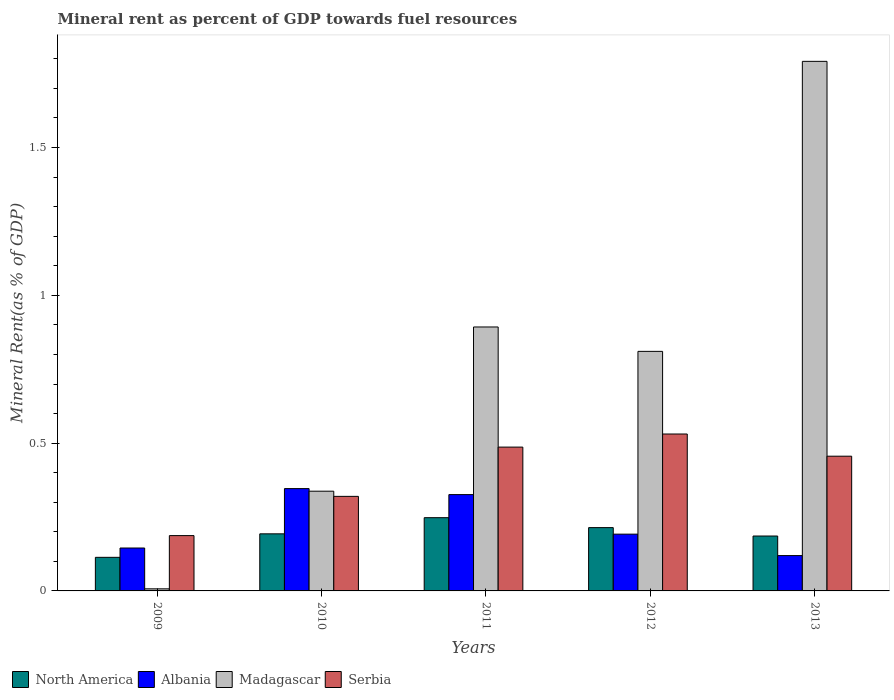How many different coloured bars are there?
Offer a terse response. 4. How many groups of bars are there?
Offer a terse response. 5. Are the number of bars per tick equal to the number of legend labels?
Keep it short and to the point. Yes. Are the number of bars on each tick of the X-axis equal?
Provide a succinct answer. Yes. How many bars are there on the 3rd tick from the right?
Provide a short and direct response. 4. In how many cases, is the number of bars for a given year not equal to the number of legend labels?
Your answer should be compact. 0. What is the mineral rent in Albania in 2011?
Keep it short and to the point. 0.33. Across all years, what is the maximum mineral rent in Madagascar?
Offer a very short reply. 1.79. Across all years, what is the minimum mineral rent in Serbia?
Ensure brevity in your answer.  0.19. In which year was the mineral rent in North America maximum?
Offer a terse response. 2011. What is the total mineral rent in Serbia in the graph?
Provide a short and direct response. 1.98. What is the difference between the mineral rent in Albania in 2010 and that in 2011?
Offer a terse response. 0.02. What is the difference between the mineral rent in Albania in 2011 and the mineral rent in North America in 2010?
Keep it short and to the point. 0.13. What is the average mineral rent in Albania per year?
Keep it short and to the point. 0.23. In the year 2011, what is the difference between the mineral rent in North America and mineral rent in Serbia?
Give a very brief answer. -0.24. What is the ratio of the mineral rent in North America in 2010 to that in 2012?
Provide a succinct answer. 0.9. Is the mineral rent in Madagascar in 2010 less than that in 2012?
Ensure brevity in your answer.  Yes. Is the difference between the mineral rent in North America in 2009 and 2012 greater than the difference between the mineral rent in Serbia in 2009 and 2012?
Ensure brevity in your answer.  Yes. What is the difference between the highest and the second highest mineral rent in Albania?
Make the answer very short. 0.02. What is the difference between the highest and the lowest mineral rent in Madagascar?
Your response must be concise. 1.78. In how many years, is the mineral rent in Albania greater than the average mineral rent in Albania taken over all years?
Provide a succinct answer. 2. Is the sum of the mineral rent in Serbia in 2011 and 2013 greater than the maximum mineral rent in Madagascar across all years?
Offer a terse response. No. Is it the case that in every year, the sum of the mineral rent in Madagascar and mineral rent in North America is greater than the sum of mineral rent in Serbia and mineral rent in Albania?
Keep it short and to the point. No. What does the 4th bar from the left in 2010 represents?
Your response must be concise. Serbia. What does the 1st bar from the right in 2012 represents?
Give a very brief answer. Serbia. Are the values on the major ticks of Y-axis written in scientific E-notation?
Your answer should be compact. No. Does the graph contain any zero values?
Your answer should be very brief. No. Where does the legend appear in the graph?
Give a very brief answer. Bottom left. How many legend labels are there?
Provide a succinct answer. 4. How are the legend labels stacked?
Provide a short and direct response. Horizontal. What is the title of the graph?
Keep it short and to the point. Mineral rent as percent of GDP towards fuel resources. Does "Namibia" appear as one of the legend labels in the graph?
Your response must be concise. No. What is the label or title of the Y-axis?
Offer a terse response. Mineral Rent(as % of GDP). What is the Mineral Rent(as % of GDP) of North America in 2009?
Keep it short and to the point. 0.11. What is the Mineral Rent(as % of GDP) in Albania in 2009?
Provide a succinct answer. 0.15. What is the Mineral Rent(as % of GDP) of Madagascar in 2009?
Offer a very short reply. 0.01. What is the Mineral Rent(as % of GDP) in Serbia in 2009?
Provide a succinct answer. 0.19. What is the Mineral Rent(as % of GDP) of North America in 2010?
Your answer should be very brief. 0.19. What is the Mineral Rent(as % of GDP) of Albania in 2010?
Give a very brief answer. 0.35. What is the Mineral Rent(as % of GDP) of Madagascar in 2010?
Offer a terse response. 0.34. What is the Mineral Rent(as % of GDP) of Serbia in 2010?
Your answer should be compact. 0.32. What is the Mineral Rent(as % of GDP) of North America in 2011?
Provide a succinct answer. 0.25. What is the Mineral Rent(as % of GDP) in Albania in 2011?
Your answer should be compact. 0.33. What is the Mineral Rent(as % of GDP) of Madagascar in 2011?
Keep it short and to the point. 0.89. What is the Mineral Rent(as % of GDP) of Serbia in 2011?
Keep it short and to the point. 0.49. What is the Mineral Rent(as % of GDP) in North America in 2012?
Offer a terse response. 0.21. What is the Mineral Rent(as % of GDP) of Albania in 2012?
Your answer should be very brief. 0.19. What is the Mineral Rent(as % of GDP) in Madagascar in 2012?
Ensure brevity in your answer.  0.81. What is the Mineral Rent(as % of GDP) of Serbia in 2012?
Your response must be concise. 0.53. What is the Mineral Rent(as % of GDP) of North America in 2013?
Provide a short and direct response. 0.19. What is the Mineral Rent(as % of GDP) in Albania in 2013?
Your response must be concise. 0.12. What is the Mineral Rent(as % of GDP) in Madagascar in 2013?
Provide a short and direct response. 1.79. What is the Mineral Rent(as % of GDP) in Serbia in 2013?
Provide a succinct answer. 0.46. Across all years, what is the maximum Mineral Rent(as % of GDP) of North America?
Ensure brevity in your answer.  0.25. Across all years, what is the maximum Mineral Rent(as % of GDP) in Albania?
Provide a succinct answer. 0.35. Across all years, what is the maximum Mineral Rent(as % of GDP) in Madagascar?
Make the answer very short. 1.79. Across all years, what is the maximum Mineral Rent(as % of GDP) of Serbia?
Your answer should be compact. 0.53. Across all years, what is the minimum Mineral Rent(as % of GDP) of North America?
Offer a very short reply. 0.11. Across all years, what is the minimum Mineral Rent(as % of GDP) in Albania?
Keep it short and to the point. 0.12. Across all years, what is the minimum Mineral Rent(as % of GDP) of Madagascar?
Ensure brevity in your answer.  0.01. Across all years, what is the minimum Mineral Rent(as % of GDP) in Serbia?
Offer a very short reply. 0.19. What is the total Mineral Rent(as % of GDP) of North America in the graph?
Your answer should be compact. 0.95. What is the total Mineral Rent(as % of GDP) in Albania in the graph?
Your answer should be very brief. 1.13. What is the total Mineral Rent(as % of GDP) of Madagascar in the graph?
Your answer should be very brief. 3.84. What is the total Mineral Rent(as % of GDP) in Serbia in the graph?
Your answer should be compact. 1.98. What is the difference between the Mineral Rent(as % of GDP) in North America in 2009 and that in 2010?
Your answer should be very brief. -0.08. What is the difference between the Mineral Rent(as % of GDP) in Albania in 2009 and that in 2010?
Provide a succinct answer. -0.2. What is the difference between the Mineral Rent(as % of GDP) in Madagascar in 2009 and that in 2010?
Your answer should be very brief. -0.33. What is the difference between the Mineral Rent(as % of GDP) of Serbia in 2009 and that in 2010?
Provide a succinct answer. -0.13. What is the difference between the Mineral Rent(as % of GDP) of North America in 2009 and that in 2011?
Give a very brief answer. -0.13. What is the difference between the Mineral Rent(as % of GDP) of Albania in 2009 and that in 2011?
Offer a terse response. -0.18. What is the difference between the Mineral Rent(as % of GDP) of Madagascar in 2009 and that in 2011?
Offer a very short reply. -0.89. What is the difference between the Mineral Rent(as % of GDP) of Serbia in 2009 and that in 2011?
Give a very brief answer. -0.3. What is the difference between the Mineral Rent(as % of GDP) of North America in 2009 and that in 2012?
Provide a succinct answer. -0.1. What is the difference between the Mineral Rent(as % of GDP) of Albania in 2009 and that in 2012?
Make the answer very short. -0.05. What is the difference between the Mineral Rent(as % of GDP) of Madagascar in 2009 and that in 2012?
Offer a very short reply. -0.8. What is the difference between the Mineral Rent(as % of GDP) in Serbia in 2009 and that in 2012?
Ensure brevity in your answer.  -0.34. What is the difference between the Mineral Rent(as % of GDP) in North America in 2009 and that in 2013?
Give a very brief answer. -0.07. What is the difference between the Mineral Rent(as % of GDP) of Albania in 2009 and that in 2013?
Ensure brevity in your answer.  0.03. What is the difference between the Mineral Rent(as % of GDP) in Madagascar in 2009 and that in 2013?
Make the answer very short. -1.78. What is the difference between the Mineral Rent(as % of GDP) of Serbia in 2009 and that in 2013?
Give a very brief answer. -0.27. What is the difference between the Mineral Rent(as % of GDP) in North America in 2010 and that in 2011?
Your answer should be compact. -0.05. What is the difference between the Mineral Rent(as % of GDP) in Albania in 2010 and that in 2011?
Offer a very short reply. 0.02. What is the difference between the Mineral Rent(as % of GDP) of Madagascar in 2010 and that in 2011?
Offer a terse response. -0.56. What is the difference between the Mineral Rent(as % of GDP) of North America in 2010 and that in 2012?
Your answer should be compact. -0.02. What is the difference between the Mineral Rent(as % of GDP) of Albania in 2010 and that in 2012?
Your answer should be very brief. 0.15. What is the difference between the Mineral Rent(as % of GDP) of Madagascar in 2010 and that in 2012?
Ensure brevity in your answer.  -0.47. What is the difference between the Mineral Rent(as % of GDP) in Serbia in 2010 and that in 2012?
Your answer should be very brief. -0.21. What is the difference between the Mineral Rent(as % of GDP) in North America in 2010 and that in 2013?
Provide a succinct answer. 0.01. What is the difference between the Mineral Rent(as % of GDP) in Albania in 2010 and that in 2013?
Your answer should be compact. 0.23. What is the difference between the Mineral Rent(as % of GDP) in Madagascar in 2010 and that in 2013?
Offer a very short reply. -1.45. What is the difference between the Mineral Rent(as % of GDP) in Serbia in 2010 and that in 2013?
Provide a succinct answer. -0.14. What is the difference between the Mineral Rent(as % of GDP) in North America in 2011 and that in 2012?
Make the answer very short. 0.03. What is the difference between the Mineral Rent(as % of GDP) in Albania in 2011 and that in 2012?
Your answer should be compact. 0.13. What is the difference between the Mineral Rent(as % of GDP) in Madagascar in 2011 and that in 2012?
Your answer should be compact. 0.08. What is the difference between the Mineral Rent(as % of GDP) in Serbia in 2011 and that in 2012?
Provide a short and direct response. -0.04. What is the difference between the Mineral Rent(as % of GDP) in North America in 2011 and that in 2013?
Your response must be concise. 0.06. What is the difference between the Mineral Rent(as % of GDP) of Albania in 2011 and that in 2013?
Offer a terse response. 0.21. What is the difference between the Mineral Rent(as % of GDP) in Madagascar in 2011 and that in 2013?
Provide a short and direct response. -0.9. What is the difference between the Mineral Rent(as % of GDP) in Serbia in 2011 and that in 2013?
Your response must be concise. 0.03. What is the difference between the Mineral Rent(as % of GDP) in North America in 2012 and that in 2013?
Offer a terse response. 0.03. What is the difference between the Mineral Rent(as % of GDP) in Albania in 2012 and that in 2013?
Offer a terse response. 0.07. What is the difference between the Mineral Rent(as % of GDP) in Madagascar in 2012 and that in 2013?
Keep it short and to the point. -0.98. What is the difference between the Mineral Rent(as % of GDP) in Serbia in 2012 and that in 2013?
Keep it short and to the point. 0.07. What is the difference between the Mineral Rent(as % of GDP) of North America in 2009 and the Mineral Rent(as % of GDP) of Albania in 2010?
Ensure brevity in your answer.  -0.23. What is the difference between the Mineral Rent(as % of GDP) in North America in 2009 and the Mineral Rent(as % of GDP) in Madagascar in 2010?
Give a very brief answer. -0.22. What is the difference between the Mineral Rent(as % of GDP) of North America in 2009 and the Mineral Rent(as % of GDP) of Serbia in 2010?
Offer a very short reply. -0.21. What is the difference between the Mineral Rent(as % of GDP) of Albania in 2009 and the Mineral Rent(as % of GDP) of Madagascar in 2010?
Your answer should be very brief. -0.19. What is the difference between the Mineral Rent(as % of GDP) in Albania in 2009 and the Mineral Rent(as % of GDP) in Serbia in 2010?
Ensure brevity in your answer.  -0.17. What is the difference between the Mineral Rent(as % of GDP) in Madagascar in 2009 and the Mineral Rent(as % of GDP) in Serbia in 2010?
Keep it short and to the point. -0.31. What is the difference between the Mineral Rent(as % of GDP) of North America in 2009 and the Mineral Rent(as % of GDP) of Albania in 2011?
Your response must be concise. -0.21. What is the difference between the Mineral Rent(as % of GDP) of North America in 2009 and the Mineral Rent(as % of GDP) of Madagascar in 2011?
Offer a very short reply. -0.78. What is the difference between the Mineral Rent(as % of GDP) of North America in 2009 and the Mineral Rent(as % of GDP) of Serbia in 2011?
Offer a very short reply. -0.37. What is the difference between the Mineral Rent(as % of GDP) in Albania in 2009 and the Mineral Rent(as % of GDP) in Madagascar in 2011?
Offer a terse response. -0.75. What is the difference between the Mineral Rent(as % of GDP) of Albania in 2009 and the Mineral Rent(as % of GDP) of Serbia in 2011?
Keep it short and to the point. -0.34. What is the difference between the Mineral Rent(as % of GDP) of Madagascar in 2009 and the Mineral Rent(as % of GDP) of Serbia in 2011?
Your answer should be compact. -0.48. What is the difference between the Mineral Rent(as % of GDP) of North America in 2009 and the Mineral Rent(as % of GDP) of Albania in 2012?
Your answer should be compact. -0.08. What is the difference between the Mineral Rent(as % of GDP) in North America in 2009 and the Mineral Rent(as % of GDP) in Madagascar in 2012?
Give a very brief answer. -0.7. What is the difference between the Mineral Rent(as % of GDP) of North America in 2009 and the Mineral Rent(as % of GDP) of Serbia in 2012?
Provide a short and direct response. -0.42. What is the difference between the Mineral Rent(as % of GDP) of Albania in 2009 and the Mineral Rent(as % of GDP) of Madagascar in 2012?
Your answer should be compact. -0.67. What is the difference between the Mineral Rent(as % of GDP) in Albania in 2009 and the Mineral Rent(as % of GDP) in Serbia in 2012?
Ensure brevity in your answer.  -0.39. What is the difference between the Mineral Rent(as % of GDP) in Madagascar in 2009 and the Mineral Rent(as % of GDP) in Serbia in 2012?
Provide a short and direct response. -0.52. What is the difference between the Mineral Rent(as % of GDP) of North America in 2009 and the Mineral Rent(as % of GDP) of Albania in 2013?
Give a very brief answer. -0.01. What is the difference between the Mineral Rent(as % of GDP) in North America in 2009 and the Mineral Rent(as % of GDP) in Madagascar in 2013?
Your answer should be very brief. -1.68. What is the difference between the Mineral Rent(as % of GDP) in North America in 2009 and the Mineral Rent(as % of GDP) in Serbia in 2013?
Make the answer very short. -0.34. What is the difference between the Mineral Rent(as % of GDP) in Albania in 2009 and the Mineral Rent(as % of GDP) in Madagascar in 2013?
Give a very brief answer. -1.65. What is the difference between the Mineral Rent(as % of GDP) of Albania in 2009 and the Mineral Rent(as % of GDP) of Serbia in 2013?
Keep it short and to the point. -0.31. What is the difference between the Mineral Rent(as % of GDP) in Madagascar in 2009 and the Mineral Rent(as % of GDP) in Serbia in 2013?
Your answer should be very brief. -0.45. What is the difference between the Mineral Rent(as % of GDP) in North America in 2010 and the Mineral Rent(as % of GDP) in Albania in 2011?
Keep it short and to the point. -0.13. What is the difference between the Mineral Rent(as % of GDP) of North America in 2010 and the Mineral Rent(as % of GDP) of Madagascar in 2011?
Ensure brevity in your answer.  -0.7. What is the difference between the Mineral Rent(as % of GDP) of North America in 2010 and the Mineral Rent(as % of GDP) of Serbia in 2011?
Your response must be concise. -0.29. What is the difference between the Mineral Rent(as % of GDP) in Albania in 2010 and the Mineral Rent(as % of GDP) in Madagascar in 2011?
Your response must be concise. -0.55. What is the difference between the Mineral Rent(as % of GDP) of Albania in 2010 and the Mineral Rent(as % of GDP) of Serbia in 2011?
Your response must be concise. -0.14. What is the difference between the Mineral Rent(as % of GDP) in Madagascar in 2010 and the Mineral Rent(as % of GDP) in Serbia in 2011?
Your response must be concise. -0.15. What is the difference between the Mineral Rent(as % of GDP) of North America in 2010 and the Mineral Rent(as % of GDP) of Albania in 2012?
Make the answer very short. 0. What is the difference between the Mineral Rent(as % of GDP) of North America in 2010 and the Mineral Rent(as % of GDP) of Madagascar in 2012?
Your answer should be compact. -0.62. What is the difference between the Mineral Rent(as % of GDP) of North America in 2010 and the Mineral Rent(as % of GDP) of Serbia in 2012?
Give a very brief answer. -0.34. What is the difference between the Mineral Rent(as % of GDP) of Albania in 2010 and the Mineral Rent(as % of GDP) of Madagascar in 2012?
Your answer should be very brief. -0.46. What is the difference between the Mineral Rent(as % of GDP) in Albania in 2010 and the Mineral Rent(as % of GDP) in Serbia in 2012?
Ensure brevity in your answer.  -0.18. What is the difference between the Mineral Rent(as % of GDP) of Madagascar in 2010 and the Mineral Rent(as % of GDP) of Serbia in 2012?
Offer a very short reply. -0.19. What is the difference between the Mineral Rent(as % of GDP) of North America in 2010 and the Mineral Rent(as % of GDP) of Albania in 2013?
Make the answer very short. 0.07. What is the difference between the Mineral Rent(as % of GDP) in North America in 2010 and the Mineral Rent(as % of GDP) in Madagascar in 2013?
Your answer should be compact. -1.6. What is the difference between the Mineral Rent(as % of GDP) in North America in 2010 and the Mineral Rent(as % of GDP) in Serbia in 2013?
Your answer should be very brief. -0.26. What is the difference between the Mineral Rent(as % of GDP) in Albania in 2010 and the Mineral Rent(as % of GDP) in Madagascar in 2013?
Offer a very short reply. -1.45. What is the difference between the Mineral Rent(as % of GDP) in Albania in 2010 and the Mineral Rent(as % of GDP) in Serbia in 2013?
Give a very brief answer. -0.11. What is the difference between the Mineral Rent(as % of GDP) of Madagascar in 2010 and the Mineral Rent(as % of GDP) of Serbia in 2013?
Provide a short and direct response. -0.12. What is the difference between the Mineral Rent(as % of GDP) of North America in 2011 and the Mineral Rent(as % of GDP) of Albania in 2012?
Provide a succinct answer. 0.06. What is the difference between the Mineral Rent(as % of GDP) in North America in 2011 and the Mineral Rent(as % of GDP) in Madagascar in 2012?
Your answer should be compact. -0.56. What is the difference between the Mineral Rent(as % of GDP) in North America in 2011 and the Mineral Rent(as % of GDP) in Serbia in 2012?
Offer a very short reply. -0.28. What is the difference between the Mineral Rent(as % of GDP) of Albania in 2011 and the Mineral Rent(as % of GDP) of Madagascar in 2012?
Make the answer very short. -0.48. What is the difference between the Mineral Rent(as % of GDP) in Albania in 2011 and the Mineral Rent(as % of GDP) in Serbia in 2012?
Offer a terse response. -0.2. What is the difference between the Mineral Rent(as % of GDP) of Madagascar in 2011 and the Mineral Rent(as % of GDP) of Serbia in 2012?
Offer a very short reply. 0.36. What is the difference between the Mineral Rent(as % of GDP) of North America in 2011 and the Mineral Rent(as % of GDP) of Albania in 2013?
Ensure brevity in your answer.  0.13. What is the difference between the Mineral Rent(as % of GDP) in North America in 2011 and the Mineral Rent(as % of GDP) in Madagascar in 2013?
Ensure brevity in your answer.  -1.54. What is the difference between the Mineral Rent(as % of GDP) in North America in 2011 and the Mineral Rent(as % of GDP) in Serbia in 2013?
Provide a succinct answer. -0.21. What is the difference between the Mineral Rent(as % of GDP) of Albania in 2011 and the Mineral Rent(as % of GDP) of Madagascar in 2013?
Your answer should be compact. -1.47. What is the difference between the Mineral Rent(as % of GDP) in Albania in 2011 and the Mineral Rent(as % of GDP) in Serbia in 2013?
Make the answer very short. -0.13. What is the difference between the Mineral Rent(as % of GDP) in Madagascar in 2011 and the Mineral Rent(as % of GDP) in Serbia in 2013?
Keep it short and to the point. 0.44. What is the difference between the Mineral Rent(as % of GDP) of North America in 2012 and the Mineral Rent(as % of GDP) of Albania in 2013?
Keep it short and to the point. 0.09. What is the difference between the Mineral Rent(as % of GDP) in North America in 2012 and the Mineral Rent(as % of GDP) in Madagascar in 2013?
Provide a succinct answer. -1.58. What is the difference between the Mineral Rent(as % of GDP) of North America in 2012 and the Mineral Rent(as % of GDP) of Serbia in 2013?
Provide a short and direct response. -0.24. What is the difference between the Mineral Rent(as % of GDP) in Albania in 2012 and the Mineral Rent(as % of GDP) in Madagascar in 2013?
Offer a very short reply. -1.6. What is the difference between the Mineral Rent(as % of GDP) in Albania in 2012 and the Mineral Rent(as % of GDP) in Serbia in 2013?
Offer a very short reply. -0.26. What is the difference between the Mineral Rent(as % of GDP) of Madagascar in 2012 and the Mineral Rent(as % of GDP) of Serbia in 2013?
Offer a very short reply. 0.35. What is the average Mineral Rent(as % of GDP) in North America per year?
Offer a terse response. 0.19. What is the average Mineral Rent(as % of GDP) of Albania per year?
Your answer should be very brief. 0.23. What is the average Mineral Rent(as % of GDP) in Madagascar per year?
Provide a succinct answer. 0.77. What is the average Mineral Rent(as % of GDP) of Serbia per year?
Offer a terse response. 0.4. In the year 2009, what is the difference between the Mineral Rent(as % of GDP) of North America and Mineral Rent(as % of GDP) of Albania?
Your answer should be very brief. -0.03. In the year 2009, what is the difference between the Mineral Rent(as % of GDP) in North America and Mineral Rent(as % of GDP) in Madagascar?
Give a very brief answer. 0.11. In the year 2009, what is the difference between the Mineral Rent(as % of GDP) in North America and Mineral Rent(as % of GDP) in Serbia?
Your response must be concise. -0.07. In the year 2009, what is the difference between the Mineral Rent(as % of GDP) in Albania and Mineral Rent(as % of GDP) in Madagascar?
Offer a very short reply. 0.14. In the year 2009, what is the difference between the Mineral Rent(as % of GDP) in Albania and Mineral Rent(as % of GDP) in Serbia?
Your answer should be very brief. -0.04. In the year 2009, what is the difference between the Mineral Rent(as % of GDP) of Madagascar and Mineral Rent(as % of GDP) of Serbia?
Your response must be concise. -0.18. In the year 2010, what is the difference between the Mineral Rent(as % of GDP) in North America and Mineral Rent(as % of GDP) in Albania?
Give a very brief answer. -0.15. In the year 2010, what is the difference between the Mineral Rent(as % of GDP) in North America and Mineral Rent(as % of GDP) in Madagascar?
Give a very brief answer. -0.14. In the year 2010, what is the difference between the Mineral Rent(as % of GDP) of North America and Mineral Rent(as % of GDP) of Serbia?
Your answer should be compact. -0.13. In the year 2010, what is the difference between the Mineral Rent(as % of GDP) in Albania and Mineral Rent(as % of GDP) in Madagascar?
Give a very brief answer. 0.01. In the year 2010, what is the difference between the Mineral Rent(as % of GDP) of Albania and Mineral Rent(as % of GDP) of Serbia?
Your answer should be compact. 0.03. In the year 2010, what is the difference between the Mineral Rent(as % of GDP) of Madagascar and Mineral Rent(as % of GDP) of Serbia?
Offer a terse response. 0.02. In the year 2011, what is the difference between the Mineral Rent(as % of GDP) in North America and Mineral Rent(as % of GDP) in Albania?
Make the answer very short. -0.08. In the year 2011, what is the difference between the Mineral Rent(as % of GDP) of North America and Mineral Rent(as % of GDP) of Madagascar?
Your answer should be very brief. -0.65. In the year 2011, what is the difference between the Mineral Rent(as % of GDP) in North America and Mineral Rent(as % of GDP) in Serbia?
Your answer should be very brief. -0.24. In the year 2011, what is the difference between the Mineral Rent(as % of GDP) of Albania and Mineral Rent(as % of GDP) of Madagascar?
Your answer should be compact. -0.57. In the year 2011, what is the difference between the Mineral Rent(as % of GDP) in Albania and Mineral Rent(as % of GDP) in Serbia?
Make the answer very short. -0.16. In the year 2011, what is the difference between the Mineral Rent(as % of GDP) of Madagascar and Mineral Rent(as % of GDP) of Serbia?
Offer a very short reply. 0.41. In the year 2012, what is the difference between the Mineral Rent(as % of GDP) of North America and Mineral Rent(as % of GDP) of Albania?
Offer a very short reply. 0.02. In the year 2012, what is the difference between the Mineral Rent(as % of GDP) in North America and Mineral Rent(as % of GDP) in Madagascar?
Provide a succinct answer. -0.6. In the year 2012, what is the difference between the Mineral Rent(as % of GDP) in North America and Mineral Rent(as % of GDP) in Serbia?
Provide a short and direct response. -0.32. In the year 2012, what is the difference between the Mineral Rent(as % of GDP) of Albania and Mineral Rent(as % of GDP) of Madagascar?
Keep it short and to the point. -0.62. In the year 2012, what is the difference between the Mineral Rent(as % of GDP) of Albania and Mineral Rent(as % of GDP) of Serbia?
Provide a succinct answer. -0.34. In the year 2012, what is the difference between the Mineral Rent(as % of GDP) in Madagascar and Mineral Rent(as % of GDP) in Serbia?
Provide a short and direct response. 0.28. In the year 2013, what is the difference between the Mineral Rent(as % of GDP) of North America and Mineral Rent(as % of GDP) of Albania?
Offer a very short reply. 0.07. In the year 2013, what is the difference between the Mineral Rent(as % of GDP) of North America and Mineral Rent(as % of GDP) of Madagascar?
Make the answer very short. -1.61. In the year 2013, what is the difference between the Mineral Rent(as % of GDP) of North America and Mineral Rent(as % of GDP) of Serbia?
Give a very brief answer. -0.27. In the year 2013, what is the difference between the Mineral Rent(as % of GDP) in Albania and Mineral Rent(as % of GDP) in Madagascar?
Provide a succinct answer. -1.67. In the year 2013, what is the difference between the Mineral Rent(as % of GDP) of Albania and Mineral Rent(as % of GDP) of Serbia?
Your response must be concise. -0.34. In the year 2013, what is the difference between the Mineral Rent(as % of GDP) in Madagascar and Mineral Rent(as % of GDP) in Serbia?
Provide a short and direct response. 1.34. What is the ratio of the Mineral Rent(as % of GDP) of North America in 2009 to that in 2010?
Offer a very short reply. 0.59. What is the ratio of the Mineral Rent(as % of GDP) of Albania in 2009 to that in 2010?
Offer a terse response. 0.42. What is the ratio of the Mineral Rent(as % of GDP) of Madagascar in 2009 to that in 2010?
Keep it short and to the point. 0.02. What is the ratio of the Mineral Rent(as % of GDP) in Serbia in 2009 to that in 2010?
Make the answer very short. 0.58. What is the ratio of the Mineral Rent(as % of GDP) of North America in 2009 to that in 2011?
Provide a succinct answer. 0.46. What is the ratio of the Mineral Rent(as % of GDP) in Albania in 2009 to that in 2011?
Give a very brief answer. 0.45. What is the ratio of the Mineral Rent(as % of GDP) in Madagascar in 2009 to that in 2011?
Provide a succinct answer. 0.01. What is the ratio of the Mineral Rent(as % of GDP) of Serbia in 2009 to that in 2011?
Ensure brevity in your answer.  0.38. What is the ratio of the Mineral Rent(as % of GDP) in North America in 2009 to that in 2012?
Your answer should be very brief. 0.53. What is the ratio of the Mineral Rent(as % of GDP) in Albania in 2009 to that in 2012?
Offer a terse response. 0.76. What is the ratio of the Mineral Rent(as % of GDP) in Madagascar in 2009 to that in 2012?
Provide a short and direct response. 0.01. What is the ratio of the Mineral Rent(as % of GDP) in Serbia in 2009 to that in 2012?
Ensure brevity in your answer.  0.35. What is the ratio of the Mineral Rent(as % of GDP) of North America in 2009 to that in 2013?
Ensure brevity in your answer.  0.61. What is the ratio of the Mineral Rent(as % of GDP) of Albania in 2009 to that in 2013?
Your answer should be very brief. 1.21. What is the ratio of the Mineral Rent(as % of GDP) of Madagascar in 2009 to that in 2013?
Give a very brief answer. 0. What is the ratio of the Mineral Rent(as % of GDP) of Serbia in 2009 to that in 2013?
Make the answer very short. 0.41. What is the ratio of the Mineral Rent(as % of GDP) in North America in 2010 to that in 2011?
Your response must be concise. 0.78. What is the ratio of the Mineral Rent(as % of GDP) of Albania in 2010 to that in 2011?
Offer a very short reply. 1.06. What is the ratio of the Mineral Rent(as % of GDP) in Madagascar in 2010 to that in 2011?
Your answer should be compact. 0.38. What is the ratio of the Mineral Rent(as % of GDP) in Serbia in 2010 to that in 2011?
Give a very brief answer. 0.66. What is the ratio of the Mineral Rent(as % of GDP) in North America in 2010 to that in 2012?
Offer a terse response. 0.9. What is the ratio of the Mineral Rent(as % of GDP) of Albania in 2010 to that in 2012?
Keep it short and to the point. 1.8. What is the ratio of the Mineral Rent(as % of GDP) of Madagascar in 2010 to that in 2012?
Your answer should be compact. 0.42. What is the ratio of the Mineral Rent(as % of GDP) in Serbia in 2010 to that in 2012?
Your answer should be compact. 0.6. What is the ratio of the Mineral Rent(as % of GDP) of North America in 2010 to that in 2013?
Offer a very short reply. 1.04. What is the ratio of the Mineral Rent(as % of GDP) in Albania in 2010 to that in 2013?
Provide a succinct answer. 2.9. What is the ratio of the Mineral Rent(as % of GDP) in Madagascar in 2010 to that in 2013?
Keep it short and to the point. 0.19. What is the ratio of the Mineral Rent(as % of GDP) of Serbia in 2010 to that in 2013?
Offer a terse response. 0.7. What is the ratio of the Mineral Rent(as % of GDP) in North America in 2011 to that in 2012?
Offer a terse response. 1.16. What is the ratio of the Mineral Rent(as % of GDP) of Albania in 2011 to that in 2012?
Offer a very short reply. 1.7. What is the ratio of the Mineral Rent(as % of GDP) in Madagascar in 2011 to that in 2012?
Provide a short and direct response. 1.1. What is the ratio of the Mineral Rent(as % of GDP) in Serbia in 2011 to that in 2012?
Provide a succinct answer. 0.92. What is the ratio of the Mineral Rent(as % of GDP) of North America in 2011 to that in 2013?
Give a very brief answer. 1.33. What is the ratio of the Mineral Rent(as % of GDP) in Albania in 2011 to that in 2013?
Offer a very short reply. 2.73. What is the ratio of the Mineral Rent(as % of GDP) in Madagascar in 2011 to that in 2013?
Your answer should be compact. 0.5. What is the ratio of the Mineral Rent(as % of GDP) of Serbia in 2011 to that in 2013?
Offer a very short reply. 1.07. What is the ratio of the Mineral Rent(as % of GDP) of North America in 2012 to that in 2013?
Give a very brief answer. 1.15. What is the ratio of the Mineral Rent(as % of GDP) of Albania in 2012 to that in 2013?
Offer a terse response. 1.61. What is the ratio of the Mineral Rent(as % of GDP) in Madagascar in 2012 to that in 2013?
Your response must be concise. 0.45. What is the ratio of the Mineral Rent(as % of GDP) in Serbia in 2012 to that in 2013?
Keep it short and to the point. 1.16. What is the difference between the highest and the second highest Mineral Rent(as % of GDP) in North America?
Your response must be concise. 0.03. What is the difference between the highest and the second highest Mineral Rent(as % of GDP) of Albania?
Offer a very short reply. 0.02. What is the difference between the highest and the second highest Mineral Rent(as % of GDP) in Madagascar?
Your answer should be compact. 0.9. What is the difference between the highest and the second highest Mineral Rent(as % of GDP) in Serbia?
Ensure brevity in your answer.  0.04. What is the difference between the highest and the lowest Mineral Rent(as % of GDP) of North America?
Give a very brief answer. 0.13. What is the difference between the highest and the lowest Mineral Rent(as % of GDP) in Albania?
Give a very brief answer. 0.23. What is the difference between the highest and the lowest Mineral Rent(as % of GDP) in Madagascar?
Provide a short and direct response. 1.78. What is the difference between the highest and the lowest Mineral Rent(as % of GDP) in Serbia?
Offer a terse response. 0.34. 